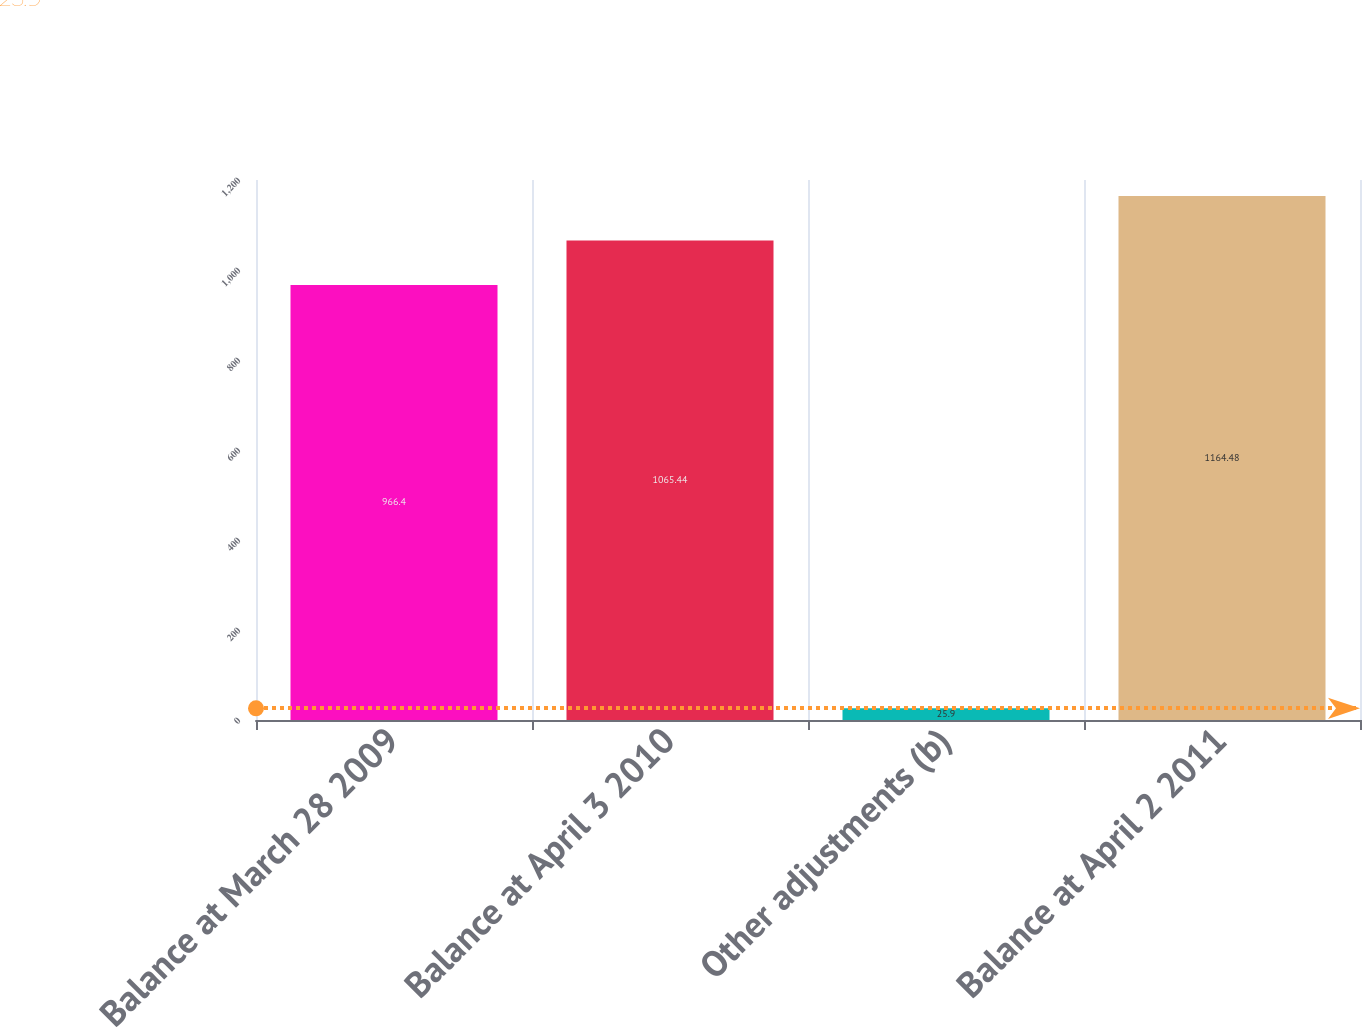Convert chart to OTSL. <chart><loc_0><loc_0><loc_500><loc_500><bar_chart><fcel>Balance at March 28 2009<fcel>Balance at April 3 2010<fcel>Other adjustments (b)<fcel>Balance at April 2 2011<nl><fcel>966.4<fcel>1065.44<fcel>25.9<fcel>1164.48<nl></chart> 